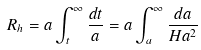<formula> <loc_0><loc_0><loc_500><loc_500>R _ { h } = a \int _ { t } ^ { \infty } \frac { d t } { a } = a \int _ { a } ^ { \infty } \frac { d a } { H a ^ { 2 } }</formula> 